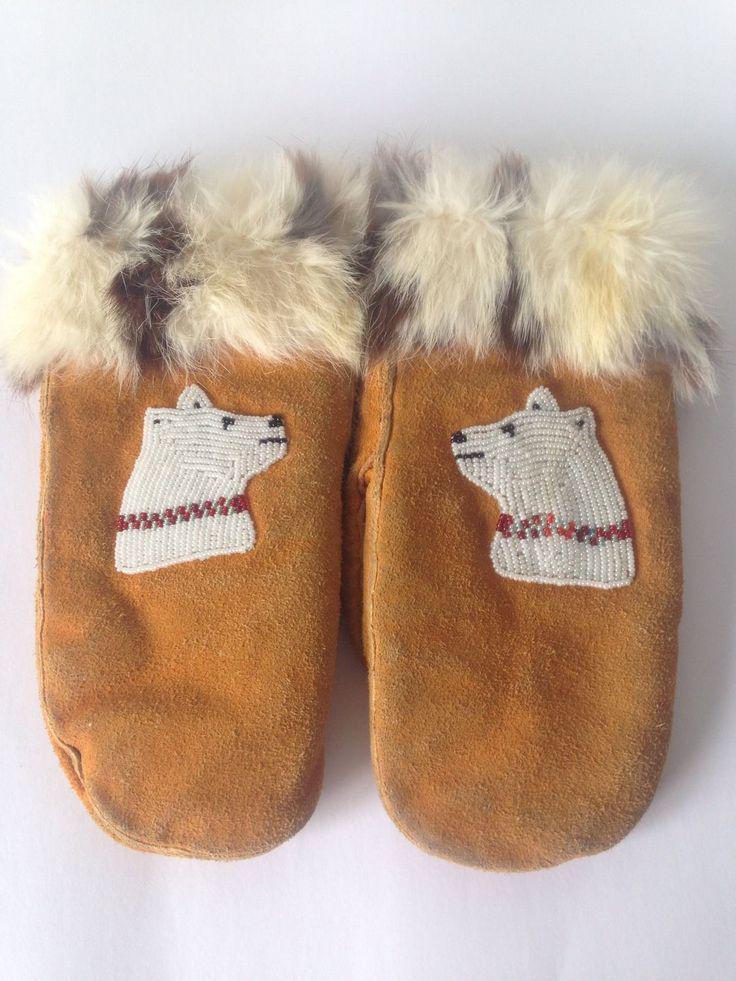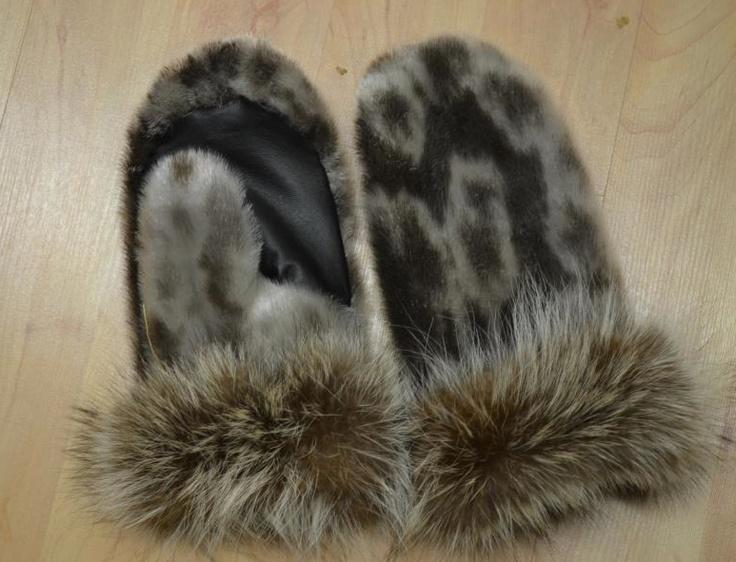The first image is the image on the left, the second image is the image on the right. Analyze the images presented: Is the assertion "A tangled cord is part of one image of mitts." valid? Answer yes or no. No. 